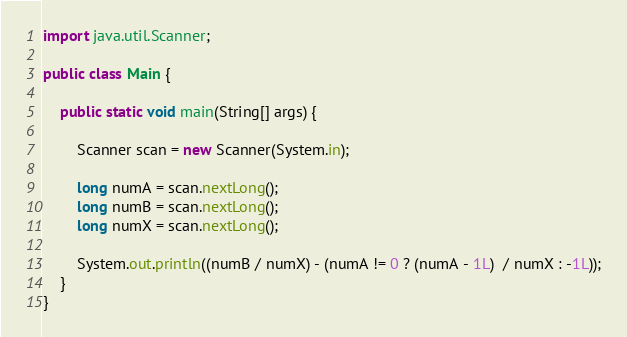<code> <loc_0><loc_0><loc_500><loc_500><_Java_>import java.util.Scanner;

public class Main {

	public static void main(String[] args) {

		Scanner scan = new Scanner(System.in);

		long numA = scan.nextLong();
		long numB = scan.nextLong();
		long numX = scan.nextLong();

		System.out.println((numB / numX) - (numA != 0 ? (numA - 1L)  / numX : -1L));
	}
}
</code> 